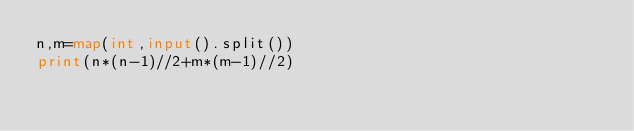Convert code to text. <code><loc_0><loc_0><loc_500><loc_500><_Python_>n,m=map(int,input().split())
print(n*(n-1)//2+m*(m-1)//2)</code> 